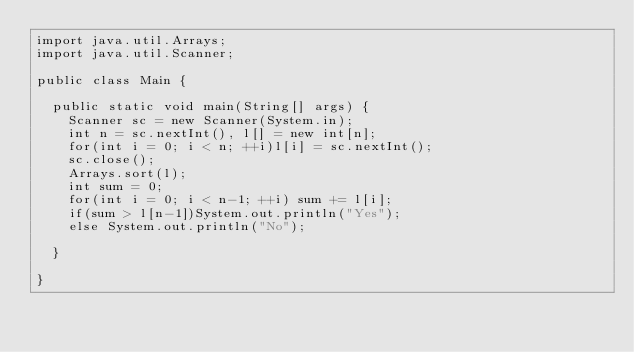<code> <loc_0><loc_0><loc_500><loc_500><_Java_>import java.util.Arrays;
import java.util.Scanner;

public class Main {

	public static void main(String[] args) {
		Scanner sc = new Scanner(System.in);
		int n = sc.nextInt(), l[] = new int[n];
		for(int i = 0; i < n; ++i)l[i] = sc.nextInt();
		sc.close();
		Arrays.sort(l);
		int sum = 0;
		for(int i = 0; i < n-1; ++i) sum += l[i];
		if(sum > l[n-1])System.out.println("Yes");
		else System.out.println("No");

	}

}
</code> 